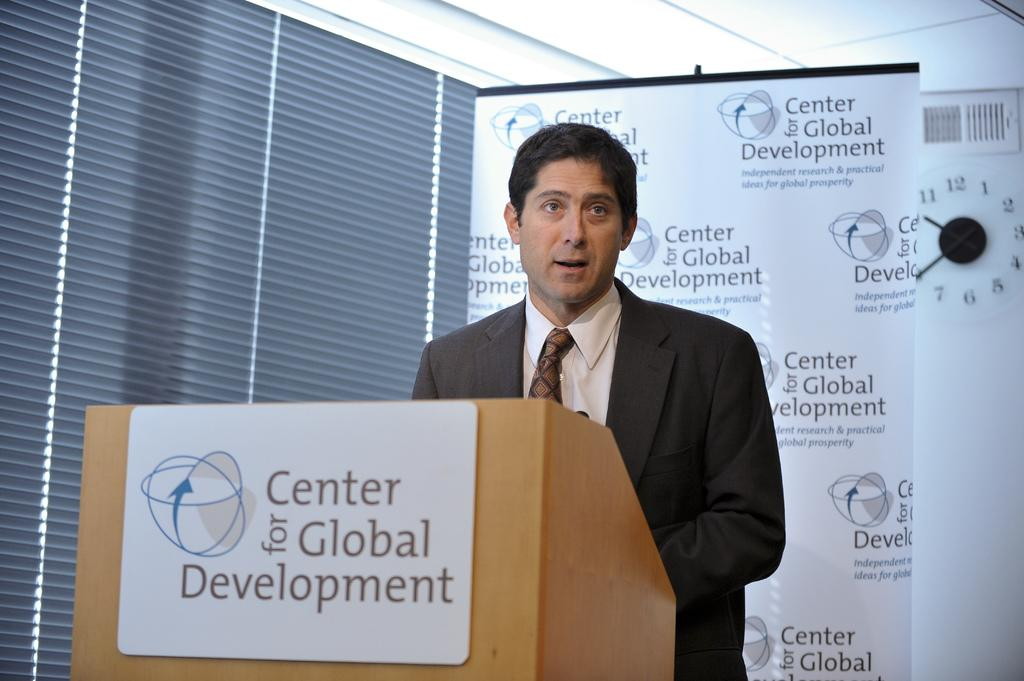What is the main subject of the image? There is a person standing in the image. What is located behind the person? There is a banner or a board behind the person. What object can be seen near the person? There is a podium with a board attached to it in the image. Can you describe any other objects in the image? There is a clock attached to the wall in the image. What does the clock smell like in the image? The clock does not have a smell, as it is an inanimate object. 